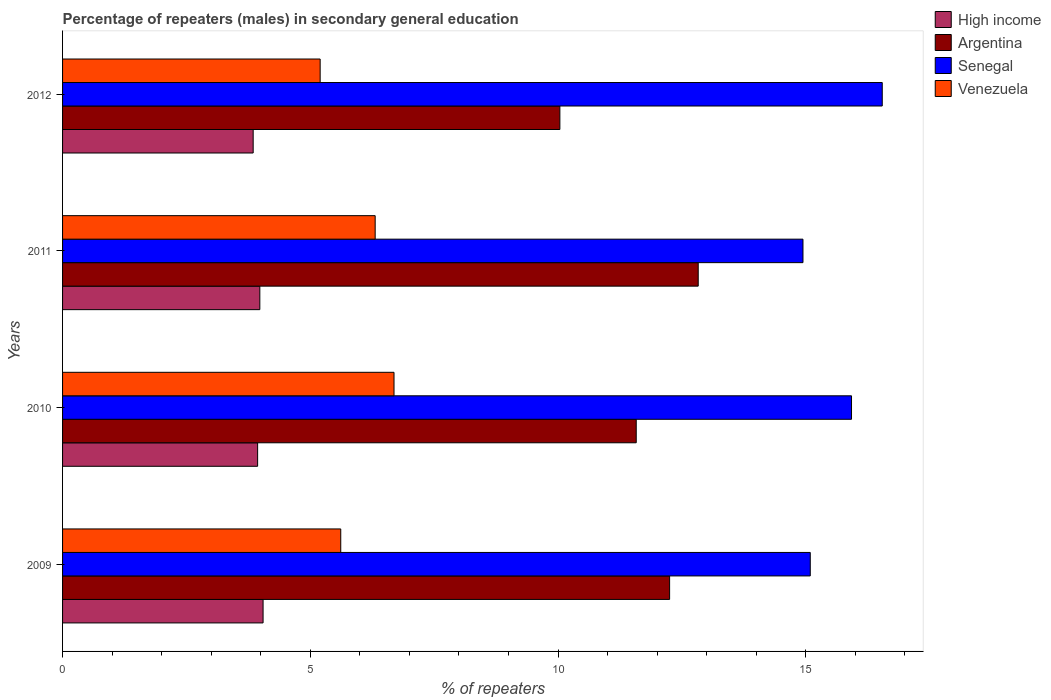Are the number of bars per tick equal to the number of legend labels?
Your answer should be compact. Yes. How many bars are there on the 4th tick from the top?
Offer a terse response. 4. In how many cases, is the number of bars for a given year not equal to the number of legend labels?
Offer a terse response. 0. What is the percentage of male repeaters in High income in 2012?
Provide a short and direct response. 3.85. Across all years, what is the maximum percentage of male repeaters in Argentina?
Provide a short and direct response. 12.83. Across all years, what is the minimum percentage of male repeaters in Venezuela?
Offer a terse response. 5.2. In which year was the percentage of male repeaters in Argentina minimum?
Provide a short and direct response. 2012. What is the total percentage of male repeaters in Argentina in the graph?
Keep it short and to the point. 46.69. What is the difference between the percentage of male repeaters in Argentina in 2009 and that in 2011?
Your response must be concise. -0.58. What is the difference between the percentage of male repeaters in Senegal in 2009 and the percentage of male repeaters in High income in 2011?
Keep it short and to the point. 11.11. What is the average percentage of male repeaters in Senegal per year?
Ensure brevity in your answer.  15.62. In the year 2011, what is the difference between the percentage of male repeaters in Argentina and percentage of male repeaters in Venezuela?
Offer a very short reply. 6.52. In how many years, is the percentage of male repeaters in High income greater than 2 %?
Your response must be concise. 4. What is the ratio of the percentage of male repeaters in Venezuela in 2011 to that in 2012?
Provide a succinct answer. 1.21. Is the percentage of male repeaters in Argentina in 2009 less than that in 2010?
Keep it short and to the point. No. What is the difference between the highest and the second highest percentage of male repeaters in Venezuela?
Your response must be concise. 0.38. What is the difference between the highest and the lowest percentage of male repeaters in Venezuela?
Provide a short and direct response. 1.49. In how many years, is the percentage of male repeaters in High income greater than the average percentage of male repeaters in High income taken over all years?
Ensure brevity in your answer.  2. What does the 2nd bar from the top in 2010 represents?
Provide a succinct answer. Senegal. What does the 3rd bar from the bottom in 2012 represents?
Provide a succinct answer. Senegal. Are all the bars in the graph horizontal?
Offer a terse response. Yes. How many years are there in the graph?
Offer a terse response. 4. Does the graph contain grids?
Give a very brief answer. No. Where does the legend appear in the graph?
Keep it short and to the point. Top right. How many legend labels are there?
Ensure brevity in your answer.  4. What is the title of the graph?
Provide a short and direct response. Percentage of repeaters (males) in secondary general education. Does "Netherlands" appear as one of the legend labels in the graph?
Your response must be concise. No. What is the label or title of the X-axis?
Keep it short and to the point. % of repeaters. What is the label or title of the Y-axis?
Give a very brief answer. Years. What is the % of repeaters in High income in 2009?
Offer a terse response. 4.05. What is the % of repeaters in Argentina in 2009?
Make the answer very short. 12.25. What is the % of repeaters of Senegal in 2009?
Keep it short and to the point. 15.09. What is the % of repeaters of Venezuela in 2009?
Your answer should be very brief. 5.61. What is the % of repeaters of High income in 2010?
Provide a short and direct response. 3.94. What is the % of repeaters in Argentina in 2010?
Keep it short and to the point. 11.58. What is the % of repeaters of Senegal in 2010?
Your answer should be compact. 15.92. What is the % of repeaters in Venezuela in 2010?
Your response must be concise. 6.69. What is the % of repeaters of High income in 2011?
Your answer should be very brief. 3.98. What is the % of repeaters of Argentina in 2011?
Keep it short and to the point. 12.83. What is the % of repeaters of Senegal in 2011?
Provide a short and direct response. 14.94. What is the % of repeaters in Venezuela in 2011?
Keep it short and to the point. 6.31. What is the % of repeaters of High income in 2012?
Your answer should be very brief. 3.85. What is the % of repeaters in Argentina in 2012?
Offer a terse response. 10.04. What is the % of repeaters of Senegal in 2012?
Your answer should be compact. 16.54. What is the % of repeaters in Venezuela in 2012?
Offer a very short reply. 5.2. Across all years, what is the maximum % of repeaters of High income?
Your answer should be compact. 4.05. Across all years, what is the maximum % of repeaters of Argentina?
Your answer should be very brief. 12.83. Across all years, what is the maximum % of repeaters in Senegal?
Offer a terse response. 16.54. Across all years, what is the maximum % of repeaters in Venezuela?
Ensure brevity in your answer.  6.69. Across all years, what is the minimum % of repeaters of High income?
Your response must be concise. 3.85. Across all years, what is the minimum % of repeaters of Argentina?
Provide a succinct answer. 10.04. Across all years, what is the minimum % of repeaters in Senegal?
Give a very brief answer. 14.94. Across all years, what is the minimum % of repeaters of Venezuela?
Your answer should be compact. 5.2. What is the total % of repeaters of High income in the graph?
Your answer should be compact. 15.81. What is the total % of repeaters in Argentina in the graph?
Keep it short and to the point. 46.69. What is the total % of repeaters in Senegal in the graph?
Your response must be concise. 62.5. What is the total % of repeaters in Venezuela in the graph?
Offer a very short reply. 23.81. What is the difference between the % of repeaters of High income in 2009 and that in 2010?
Your response must be concise. 0.11. What is the difference between the % of repeaters of Argentina in 2009 and that in 2010?
Your response must be concise. 0.67. What is the difference between the % of repeaters in Senegal in 2009 and that in 2010?
Give a very brief answer. -0.83. What is the difference between the % of repeaters of Venezuela in 2009 and that in 2010?
Ensure brevity in your answer.  -1.08. What is the difference between the % of repeaters in High income in 2009 and that in 2011?
Your answer should be compact. 0.07. What is the difference between the % of repeaters in Argentina in 2009 and that in 2011?
Keep it short and to the point. -0.58. What is the difference between the % of repeaters in Senegal in 2009 and that in 2011?
Provide a succinct answer. 0.15. What is the difference between the % of repeaters in Venezuela in 2009 and that in 2011?
Give a very brief answer. -0.69. What is the difference between the % of repeaters in High income in 2009 and that in 2012?
Offer a very short reply. 0.2. What is the difference between the % of repeaters in Argentina in 2009 and that in 2012?
Your response must be concise. 2.21. What is the difference between the % of repeaters of Senegal in 2009 and that in 2012?
Provide a short and direct response. -1.45. What is the difference between the % of repeaters of Venezuela in 2009 and that in 2012?
Your answer should be compact. 0.42. What is the difference between the % of repeaters in High income in 2010 and that in 2011?
Offer a terse response. -0.04. What is the difference between the % of repeaters in Argentina in 2010 and that in 2011?
Give a very brief answer. -1.25. What is the difference between the % of repeaters of Senegal in 2010 and that in 2011?
Offer a terse response. 0.98. What is the difference between the % of repeaters in Venezuela in 2010 and that in 2011?
Keep it short and to the point. 0.38. What is the difference between the % of repeaters in High income in 2010 and that in 2012?
Offer a very short reply. 0.09. What is the difference between the % of repeaters in Argentina in 2010 and that in 2012?
Offer a terse response. 1.54. What is the difference between the % of repeaters of Senegal in 2010 and that in 2012?
Your answer should be compact. -0.62. What is the difference between the % of repeaters in Venezuela in 2010 and that in 2012?
Provide a succinct answer. 1.49. What is the difference between the % of repeaters of High income in 2011 and that in 2012?
Offer a very short reply. 0.13. What is the difference between the % of repeaters of Argentina in 2011 and that in 2012?
Give a very brief answer. 2.79. What is the difference between the % of repeaters in Senegal in 2011 and that in 2012?
Provide a short and direct response. -1.6. What is the difference between the % of repeaters of Venezuela in 2011 and that in 2012?
Your answer should be very brief. 1.11. What is the difference between the % of repeaters of High income in 2009 and the % of repeaters of Argentina in 2010?
Ensure brevity in your answer.  -7.53. What is the difference between the % of repeaters in High income in 2009 and the % of repeaters in Senegal in 2010?
Your answer should be compact. -11.88. What is the difference between the % of repeaters of High income in 2009 and the % of repeaters of Venezuela in 2010?
Your answer should be compact. -2.64. What is the difference between the % of repeaters of Argentina in 2009 and the % of repeaters of Senegal in 2010?
Provide a succinct answer. -3.67. What is the difference between the % of repeaters of Argentina in 2009 and the % of repeaters of Venezuela in 2010?
Offer a terse response. 5.56. What is the difference between the % of repeaters in Senegal in 2009 and the % of repeaters in Venezuela in 2010?
Your response must be concise. 8.4. What is the difference between the % of repeaters in High income in 2009 and the % of repeaters in Argentina in 2011?
Ensure brevity in your answer.  -8.78. What is the difference between the % of repeaters of High income in 2009 and the % of repeaters of Senegal in 2011?
Keep it short and to the point. -10.9. What is the difference between the % of repeaters in High income in 2009 and the % of repeaters in Venezuela in 2011?
Provide a short and direct response. -2.26. What is the difference between the % of repeaters of Argentina in 2009 and the % of repeaters of Senegal in 2011?
Your answer should be very brief. -2.69. What is the difference between the % of repeaters of Argentina in 2009 and the % of repeaters of Venezuela in 2011?
Your response must be concise. 5.94. What is the difference between the % of repeaters of Senegal in 2009 and the % of repeaters of Venezuela in 2011?
Your answer should be very brief. 8.78. What is the difference between the % of repeaters in High income in 2009 and the % of repeaters in Argentina in 2012?
Your answer should be compact. -5.99. What is the difference between the % of repeaters in High income in 2009 and the % of repeaters in Senegal in 2012?
Your answer should be compact. -12.5. What is the difference between the % of repeaters of High income in 2009 and the % of repeaters of Venezuela in 2012?
Ensure brevity in your answer.  -1.15. What is the difference between the % of repeaters of Argentina in 2009 and the % of repeaters of Senegal in 2012?
Provide a short and direct response. -4.29. What is the difference between the % of repeaters in Argentina in 2009 and the % of repeaters in Venezuela in 2012?
Your answer should be compact. 7.05. What is the difference between the % of repeaters in Senegal in 2009 and the % of repeaters in Venezuela in 2012?
Your answer should be compact. 9.89. What is the difference between the % of repeaters of High income in 2010 and the % of repeaters of Argentina in 2011?
Make the answer very short. -8.89. What is the difference between the % of repeaters in High income in 2010 and the % of repeaters in Senegal in 2011?
Give a very brief answer. -11.01. What is the difference between the % of repeaters of High income in 2010 and the % of repeaters of Venezuela in 2011?
Make the answer very short. -2.37. What is the difference between the % of repeaters in Argentina in 2010 and the % of repeaters in Senegal in 2011?
Give a very brief answer. -3.37. What is the difference between the % of repeaters in Argentina in 2010 and the % of repeaters in Venezuela in 2011?
Offer a very short reply. 5.27. What is the difference between the % of repeaters in Senegal in 2010 and the % of repeaters in Venezuela in 2011?
Ensure brevity in your answer.  9.61. What is the difference between the % of repeaters in High income in 2010 and the % of repeaters in Argentina in 2012?
Your response must be concise. -6.1. What is the difference between the % of repeaters of High income in 2010 and the % of repeaters of Senegal in 2012?
Make the answer very short. -12.61. What is the difference between the % of repeaters in High income in 2010 and the % of repeaters in Venezuela in 2012?
Your answer should be compact. -1.26. What is the difference between the % of repeaters of Argentina in 2010 and the % of repeaters of Senegal in 2012?
Keep it short and to the point. -4.97. What is the difference between the % of repeaters of Argentina in 2010 and the % of repeaters of Venezuela in 2012?
Your answer should be very brief. 6.38. What is the difference between the % of repeaters in Senegal in 2010 and the % of repeaters in Venezuela in 2012?
Give a very brief answer. 10.72. What is the difference between the % of repeaters of High income in 2011 and the % of repeaters of Argentina in 2012?
Provide a short and direct response. -6.06. What is the difference between the % of repeaters in High income in 2011 and the % of repeaters in Senegal in 2012?
Offer a very short reply. -12.56. What is the difference between the % of repeaters in High income in 2011 and the % of repeaters in Venezuela in 2012?
Give a very brief answer. -1.22. What is the difference between the % of repeaters of Argentina in 2011 and the % of repeaters of Senegal in 2012?
Provide a short and direct response. -3.71. What is the difference between the % of repeaters of Argentina in 2011 and the % of repeaters of Venezuela in 2012?
Offer a terse response. 7.63. What is the difference between the % of repeaters in Senegal in 2011 and the % of repeaters in Venezuela in 2012?
Give a very brief answer. 9.74. What is the average % of repeaters of High income per year?
Keep it short and to the point. 3.95. What is the average % of repeaters of Argentina per year?
Give a very brief answer. 11.67. What is the average % of repeaters in Senegal per year?
Provide a short and direct response. 15.62. What is the average % of repeaters of Venezuela per year?
Give a very brief answer. 5.95. In the year 2009, what is the difference between the % of repeaters of High income and % of repeaters of Argentina?
Your response must be concise. -8.2. In the year 2009, what is the difference between the % of repeaters of High income and % of repeaters of Senegal?
Give a very brief answer. -11.04. In the year 2009, what is the difference between the % of repeaters of High income and % of repeaters of Venezuela?
Your answer should be compact. -1.57. In the year 2009, what is the difference between the % of repeaters of Argentina and % of repeaters of Senegal?
Your answer should be very brief. -2.84. In the year 2009, what is the difference between the % of repeaters in Argentina and % of repeaters in Venezuela?
Offer a terse response. 6.64. In the year 2009, what is the difference between the % of repeaters of Senegal and % of repeaters of Venezuela?
Keep it short and to the point. 9.48. In the year 2010, what is the difference between the % of repeaters of High income and % of repeaters of Argentina?
Your answer should be very brief. -7.64. In the year 2010, what is the difference between the % of repeaters in High income and % of repeaters in Senegal?
Ensure brevity in your answer.  -11.99. In the year 2010, what is the difference between the % of repeaters in High income and % of repeaters in Venezuela?
Your response must be concise. -2.75. In the year 2010, what is the difference between the % of repeaters in Argentina and % of repeaters in Senegal?
Provide a succinct answer. -4.34. In the year 2010, what is the difference between the % of repeaters in Argentina and % of repeaters in Venezuela?
Make the answer very short. 4.89. In the year 2010, what is the difference between the % of repeaters of Senegal and % of repeaters of Venezuela?
Your answer should be compact. 9.23. In the year 2011, what is the difference between the % of repeaters in High income and % of repeaters in Argentina?
Give a very brief answer. -8.85. In the year 2011, what is the difference between the % of repeaters of High income and % of repeaters of Senegal?
Make the answer very short. -10.96. In the year 2011, what is the difference between the % of repeaters in High income and % of repeaters in Venezuela?
Give a very brief answer. -2.33. In the year 2011, what is the difference between the % of repeaters in Argentina and % of repeaters in Senegal?
Keep it short and to the point. -2.11. In the year 2011, what is the difference between the % of repeaters in Argentina and % of repeaters in Venezuela?
Keep it short and to the point. 6.52. In the year 2011, what is the difference between the % of repeaters of Senegal and % of repeaters of Venezuela?
Provide a succinct answer. 8.63. In the year 2012, what is the difference between the % of repeaters in High income and % of repeaters in Argentina?
Your answer should be very brief. -6.19. In the year 2012, what is the difference between the % of repeaters of High income and % of repeaters of Senegal?
Offer a terse response. -12.7. In the year 2012, what is the difference between the % of repeaters in High income and % of repeaters in Venezuela?
Provide a short and direct response. -1.35. In the year 2012, what is the difference between the % of repeaters of Argentina and % of repeaters of Senegal?
Offer a very short reply. -6.51. In the year 2012, what is the difference between the % of repeaters of Argentina and % of repeaters of Venezuela?
Offer a very short reply. 4.84. In the year 2012, what is the difference between the % of repeaters in Senegal and % of repeaters in Venezuela?
Offer a terse response. 11.34. What is the ratio of the % of repeaters of High income in 2009 to that in 2010?
Offer a terse response. 1.03. What is the ratio of the % of repeaters of Argentina in 2009 to that in 2010?
Keep it short and to the point. 1.06. What is the ratio of the % of repeaters in Senegal in 2009 to that in 2010?
Provide a short and direct response. 0.95. What is the ratio of the % of repeaters in Venezuela in 2009 to that in 2010?
Your answer should be very brief. 0.84. What is the ratio of the % of repeaters of High income in 2009 to that in 2011?
Offer a terse response. 1.02. What is the ratio of the % of repeaters of Argentina in 2009 to that in 2011?
Provide a short and direct response. 0.95. What is the ratio of the % of repeaters of Senegal in 2009 to that in 2011?
Your response must be concise. 1.01. What is the ratio of the % of repeaters of Venezuela in 2009 to that in 2011?
Offer a very short reply. 0.89. What is the ratio of the % of repeaters of High income in 2009 to that in 2012?
Keep it short and to the point. 1.05. What is the ratio of the % of repeaters in Argentina in 2009 to that in 2012?
Offer a terse response. 1.22. What is the ratio of the % of repeaters of Senegal in 2009 to that in 2012?
Your answer should be very brief. 0.91. What is the ratio of the % of repeaters in Argentina in 2010 to that in 2011?
Make the answer very short. 0.9. What is the ratio of the % of repeaters of Senegal in 2010 to that in 2011?
Make the answer very short. 1.07. What is the ratio of the % of repeaters of Venezuela in 2010 to that in 2011?
Your answer should be compact. 1.06. What is the ratio of the % of repeaters of High income in 2010 to that in 2012?
Ensure brevity in your answer.  1.02. What is the ratio of the % of repeaters of Argentina in 2010 to that in 2012?
Offer a very short reply. 1.15. What is the ratio of the % of repeaters in Senegal in 2010 to that in 2012?
Give a very brief answer. 0.96. What is the ratio of the % of repeaters in Venezuela in 2010 to that in 2012?
Provide a short and direct response. 1.29. What is the ratio of the % of repeaters of High income in 2011 to that in 2012?
Your answer should be compact. 1.03. What is the ratio of the % of repeaters in Argentina in 2011 to that in 2012?
Ensure brevity in your answer.  1.28. What is the ratio of the % of repeaters in Senegal in 2011 to that in 2012?
Ensure brevity in your answer.  0.9. What is the ratio of the % of repeaters of Venezuela in 2011 to that in 2012?
Make the answer very short. 1.21. What is the difference between the highest and the second highest % of repeaters in High income?
Keep it short and to the point. 0.07. What is the difference between the highest and the second highest % of repeaters of Argentina?
Ensure brevity in your answer.  0.58. What is the difference between the highest and the second highest % of repeaters of Senegal?
Provide a succinct answer. 0.62. What is the difference between the highest and the second highest % of repeaters of Venezuela?
Offer a terse response. 0.38. What is the difference between the highest and the lowest % of repeaters of High income?
Make the answer very short. 0.2. What is the difference between the highest and the lowest % of repeaters of Argentina?
Provide a short and direct response. 2.79. What is the difference between the highest and the lowest % of repeaters of Senegal?
Your response must be concise. 1.6. What is the difference between the highest and the lowest % of repeaters of Venezuela?
Offer a terse response. 1.49. 